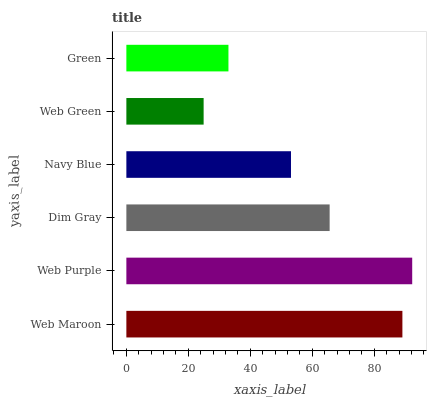Is Web Green the minimum?
Answer yes or no. Yes. Is Web Purple the maximum?
Answer yes or no. Yes. Is Dim Gray the minimum?
Answer yes or no. No. Is Dim Gray the maximum?
Answer yes or no. No. Is Web Purple greater than Dim Gray?
Answer yes or no. Yes. Is Dim Gray less than Web Purple?
Answer yes or no. Yes. Is Dim Gray greater than Web Purple?
Answer yes or no. No. Is Web Purple less than Dim Gray?
Answer yes or no. No. Is Dim Gray the high median?
Answer yes or no. Yes. Is Navy Blue the low median?
Answer yes or no. Yes. Is Web Green the high median?
Answer yes or no. No. Is Dim Gray the low median?
Answer yes or no. No. 